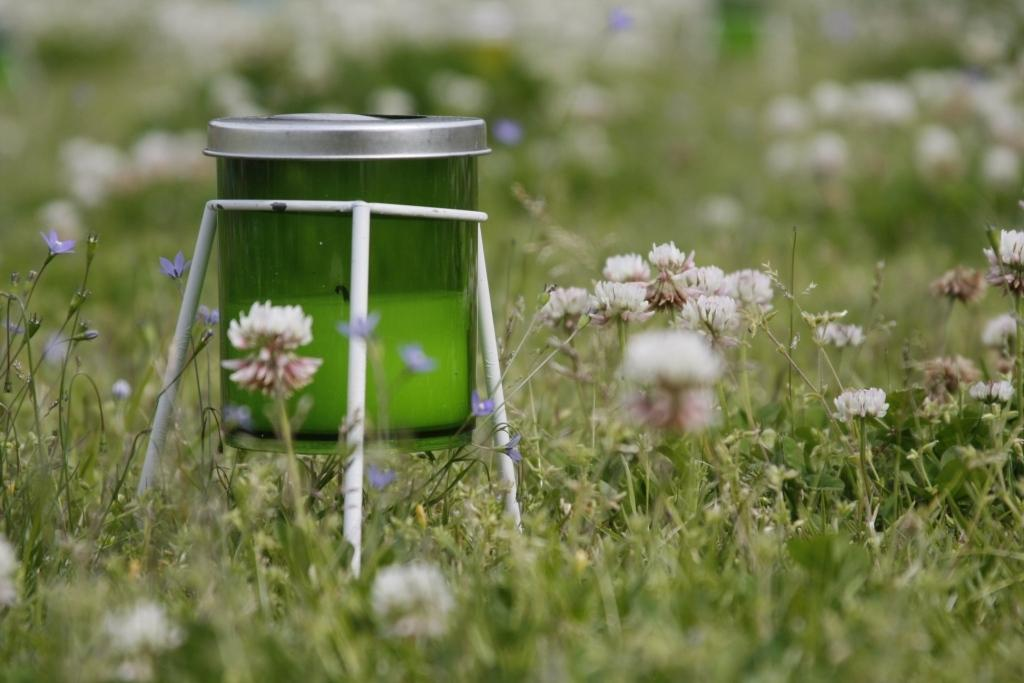What object is present in the image that can hold items? There is a jar in the image that can hold items. How is the jar positioned in the image? The jar is attached to a stand in the image. What type of flora can be seen in the image? There are flowers and plants in the image. What type of zephyr can be seen blowing through the office in the image? There is no mention of an office or a zephyr in the image. The image features a jar, a stand, flowers, and plants. 